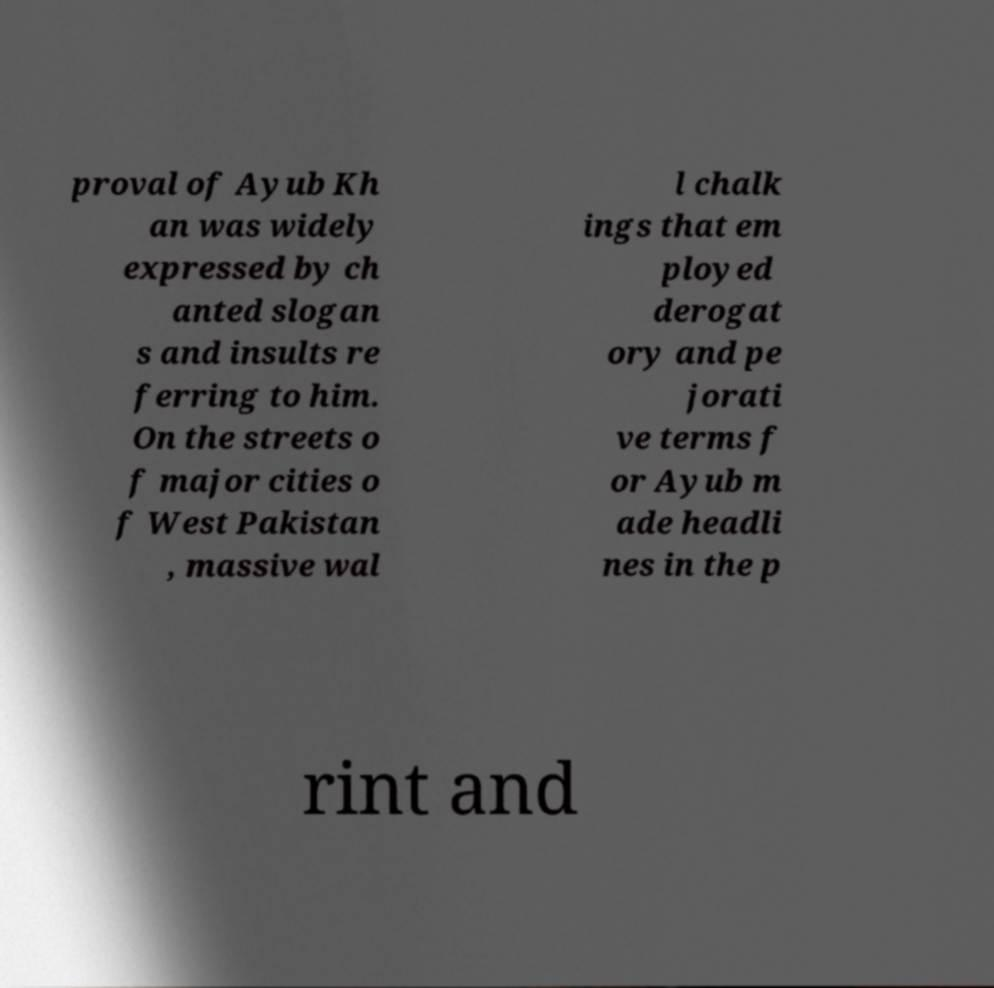There's text embedded in this image that I need extracted. Can you transcribe it verbatim? proval of Ayub Kh an was widely expressed by ch anted slogan s and insults re ferring to him. On the streets o f major cities o f West Pakistan , massive wal l chalk ings that em ployed derogat ory and pe jorati ve terms f or Ayub m ade headli nes in the p rint and 